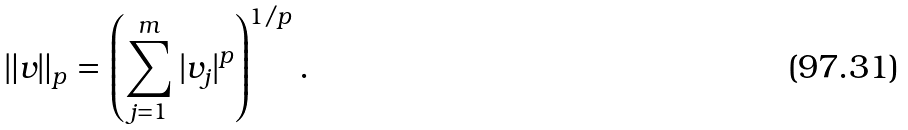Convert formula to latex. <formula><loc_0><loc_0><loc_500><loc_500>\| v \| _ { p } = \left ( \sum _ { j = 1 } ^ { m } | v _ { j } | ^ { p } \right ) ^ { 1 / p } .</formula> 